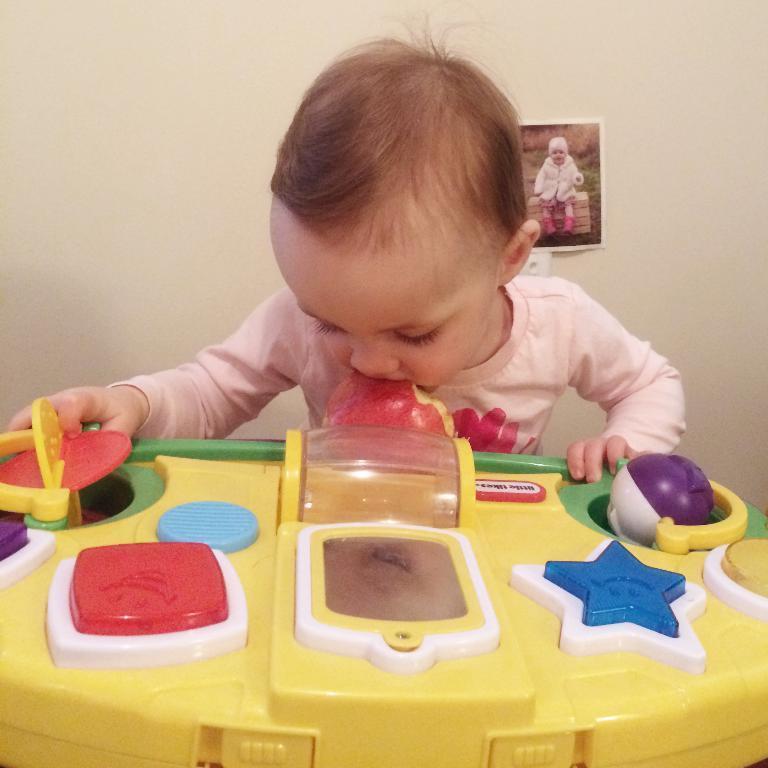Can you describe this image briefly? In this image there is a kid playing with the toy. He is keeping the toy in his mouth. In the background there is a wall to which there is a photo. 